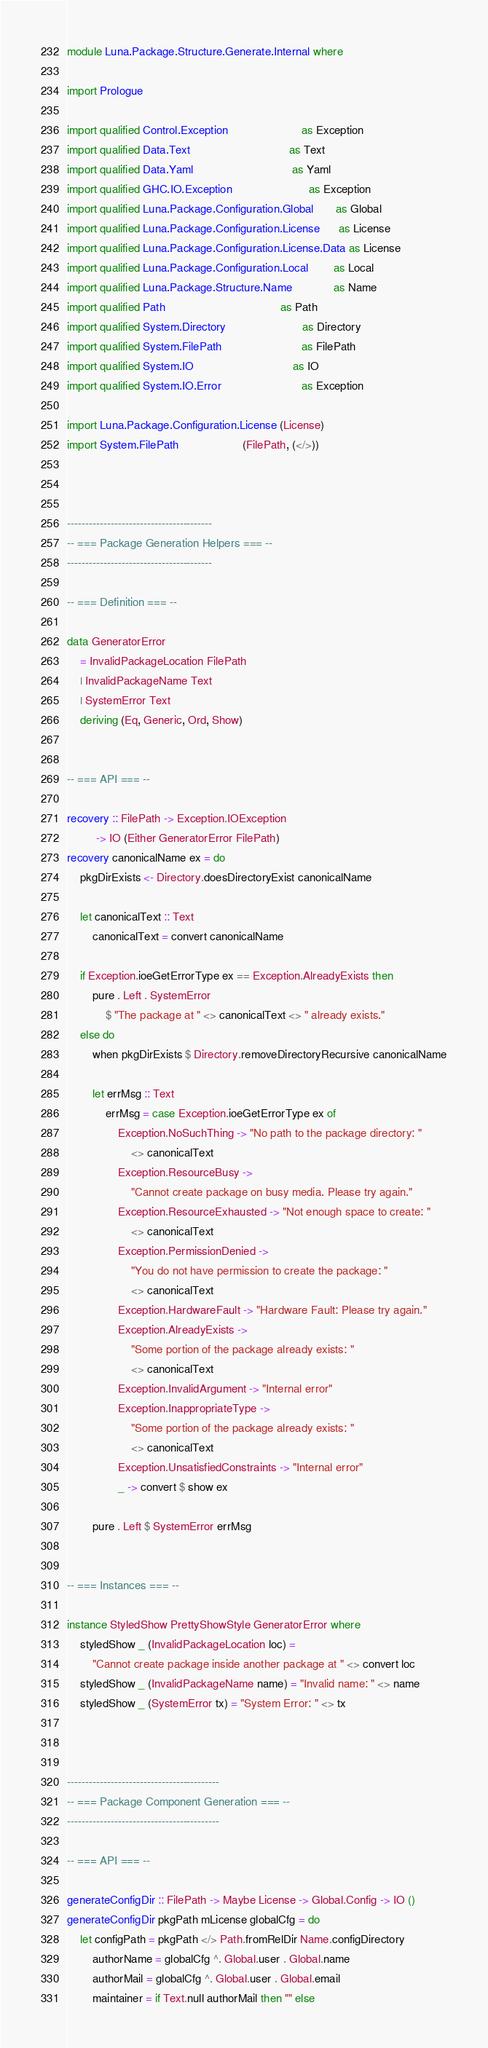Convert code to text. <code><loc_0><loc_0><loc_500><loc_500><_Haskell_>module Luna.Package.Structure.Generate.Internal where

import Prologue

import qualified Control.Exception                       as Exception
import qualified Data.Text                               as Text
import qualified Data.Yaml                               as Yaml
import qualified GHC.IO.Exception                        as Exception
import qualified Luna.Package.Configuration.Global       as Global
import qualified Luna.Package.Configuration.License      as License
import qualified Luna.Package.Configuration.License.Data as License
import qualified Luna.Package.Configuration.Local        as Local
import qualified Luna.Package.Structure.Name             as Name
import qualified Path                                    as Path
import qualified System.Directory                        as Directory
import qualified System.FilePath                         as FilePath
import qualified System.IO                               as IO
import qualified System.IO.Error                         as Exception

import Luna.Package.Configuration.License (License)
import System.FilePath                    (FilePath, (</>))



----------------------------------------
-- === Package Generation Helpers === --
----------------------------------------

-- === Definition === --

data GeneratorError
    = InvalidPackageLocation FilePath
    | InvalidPackageName Text
    | SystemError Text
    deriving (Eq, Generic, Ord, Show)


-- === API === --

recovery :: FilePath -> Exception.IOException
         -> IO (Either GeneratorError FilePath)
recovery canonicalName ex = do
    pkgDirExists <- Directory.doesDirectoryExist canonicalName

    let canonicalText :: Text
        canonicalText = convert canonicalName

    if Exception.ioeGetErrorType ex == Exception.AlreadyExists then
        pure . Left . SystemError
            $ "The package at " <> canonicalText <> " already exists."
    else do
        when pkgDirExists $ Directory.removeDirectoryRecursive canonicalName

        let errMsg :: Text
            errMsg = case Exception.ioeGetErrorType ex of
                Exception.NoSuchThing -> "No path to the package directory: "
                    <> canonicalText
                Exception.ResourceBusy ->
                    "Cannot create package on busy media. Please try again."
                Exception.ResourceExhausted -> "Not enough space to create: "
                    <> canonicalText
                Exception.PermissionDenied ->
                    "You do not have permission to create the package: "
                    <> canonicalText
                Exception.HardwareFault -> "Hardware Fault: Please try again."
                Exception.AlreadyExists ->
                    "Some portion of the package already exists: "
                    <> canonicalText
                Exception.InvalidArgument -> "Internal error"
                Exception.InappropriateType ->
                    "Some portion of the package already exists: "
                    <> canonicalText
                Exception.UnsatisfiedConstraints -> "Internal error"
                _ -> convert $ show ex

        pure . Left $ SystemError errMsg


-- === Instances === --

instance StyledShow PrettyShowStyle GeneratorError where
    styledShow _ (InvalidPackageLocation loc) =
        "Cannot create package inside another package at " <> convert loc
    styledShow _ (InvalidPackageName name) = "Invalid name: " <> name
    styledShow _ (SystemError tx) = "System Error: " <> tx



------------------------------------------
-- === Package Component Generation === --
------------------------------------------

-- === API === --

generateConfigDir :: FilePath -> Maybe License -> Global.Config -> IO ()
generateConfigDir pkgPath mLicense globalCfg = do
    let configPath = pkgPath </> Path.fromRelDir Name.configDirectory
        authorName = globalCfg ^. Global.user . Global.name
        authorMail = globalCfg ^. Global.user . Global.email
        maintainer = if Text.null authorMail then "" else</code> 